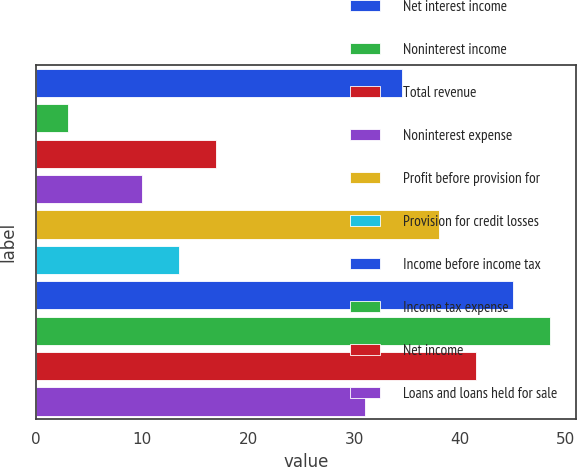Convert chart. <chart><loc_0><loc_0><loc_500><loc_500><bar_chart><fcel>Net interest income<fcel>Noninterest income<fcel>Total revenue<fcel>Noninterest expense<fcel>Profit before provision for<fcel>Provision for credit losses<fcel>Income before income tax<fcel>Income tax expense<fcel>Net income<fcel>Loans and loans held for sale<nl><fcel>34.5<fcel>3<fcel>17<fcel>10<fcel>38<fcel>13.5<fcel>45<fcel>48.5<fcel>41.5<fcel>31<nl></chart> 